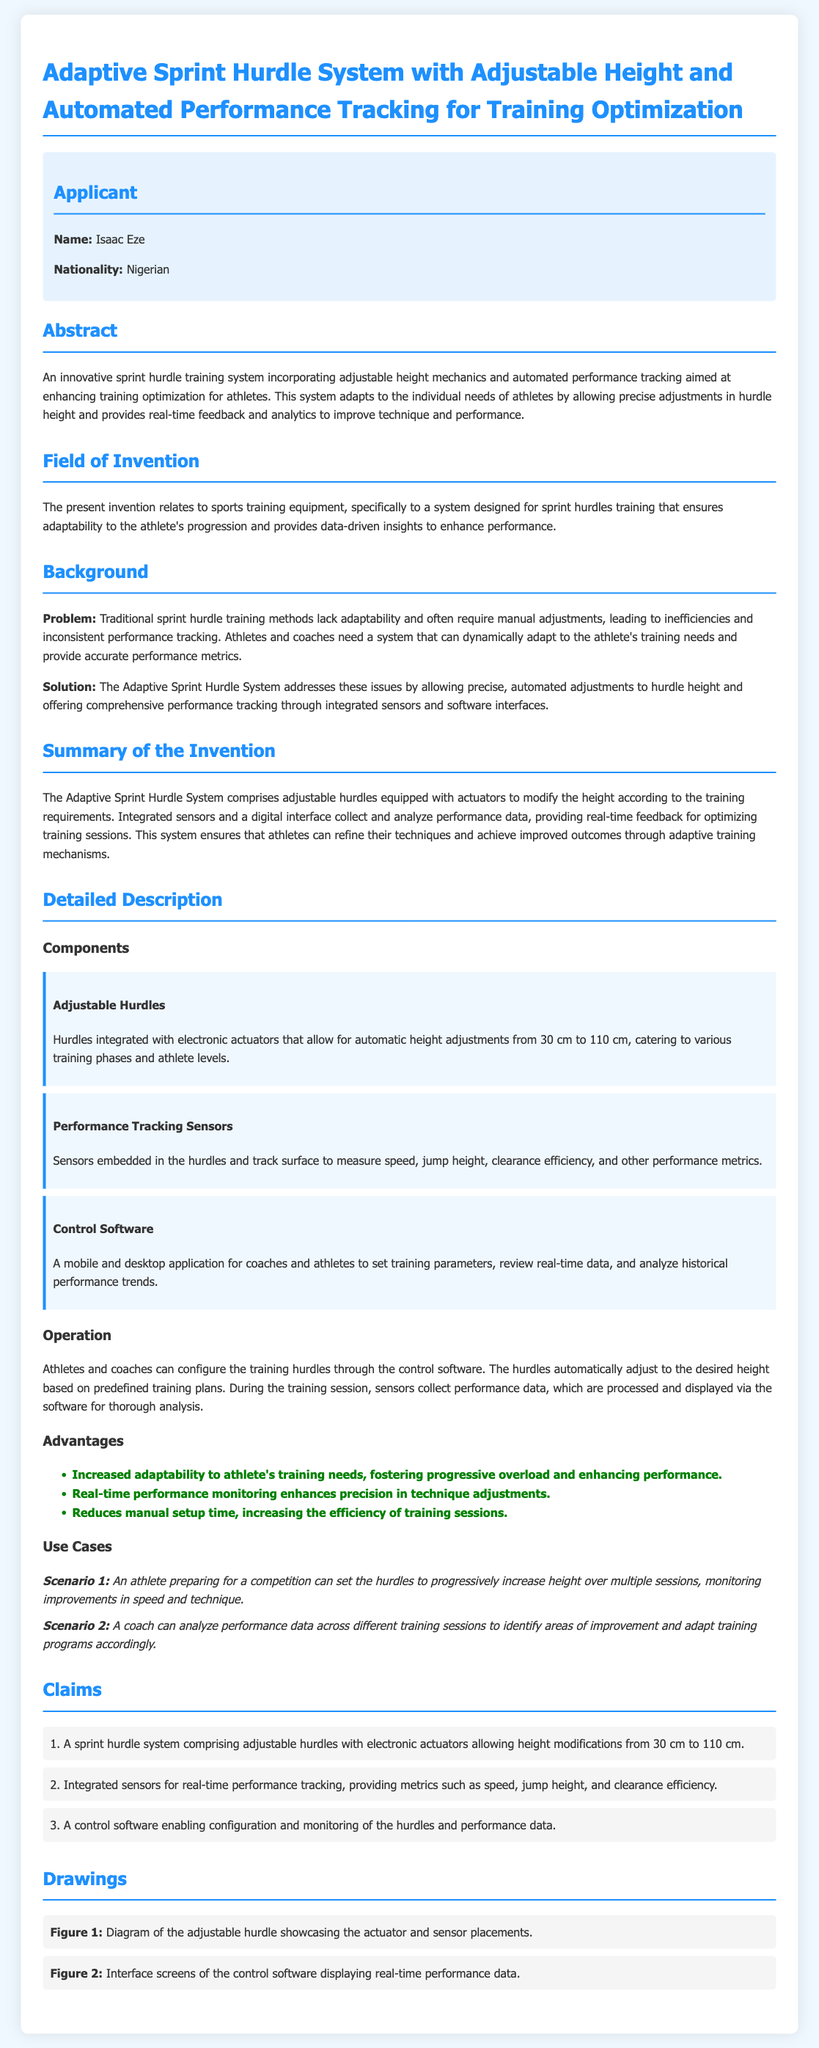What is the name of the applicant? The name of the applicant is provided in the section titled "Applicant".
Answer: Isaac Eze What is the nationality of the applicant? The nationality is mentioned in the "Applicant" section as a background detail.
Answer: Nigerian What is the adjustment height range for the hurdles? The height modification range is specified in the detailed description of the components.
Answer: 30 cm to 110 cm What does the control software allow coaches and athletes to do? The capabilities of the control software are mentioned under the "Control Software" component.
Answer: Set training parameters What is one of the problems with traditional sprint hurdle training methods? The problems with traditional methods are listed in the "Background" section.
Answer: Lack adaptability What type of feedback does the Adaptive Sprint Hurdle System provide? The type of feedback is noted in the "Summary of the Invention" section regarding performance enhancement.
Answer: Real-time feedback How many claims are made in the patent application? The number of claims is specified in the "Claims" section.
Answer: 3 What is illustrated in Figure 1? Figure 1's description gives insight into what the drawing represents as per the "Drawings" section.
Answer: Adjustable hurdle What is a use case for the system involving preparation for competition? The specific scenario is outlined in the "Use Cases" section, describing the athlete's situation.
Answer: Progressive increase height What advantage is highlighted concerning manual setup time? The advantages are detailed under a specific section that compares the new system to traditional methods.
Answer: Reduces manual setup time 